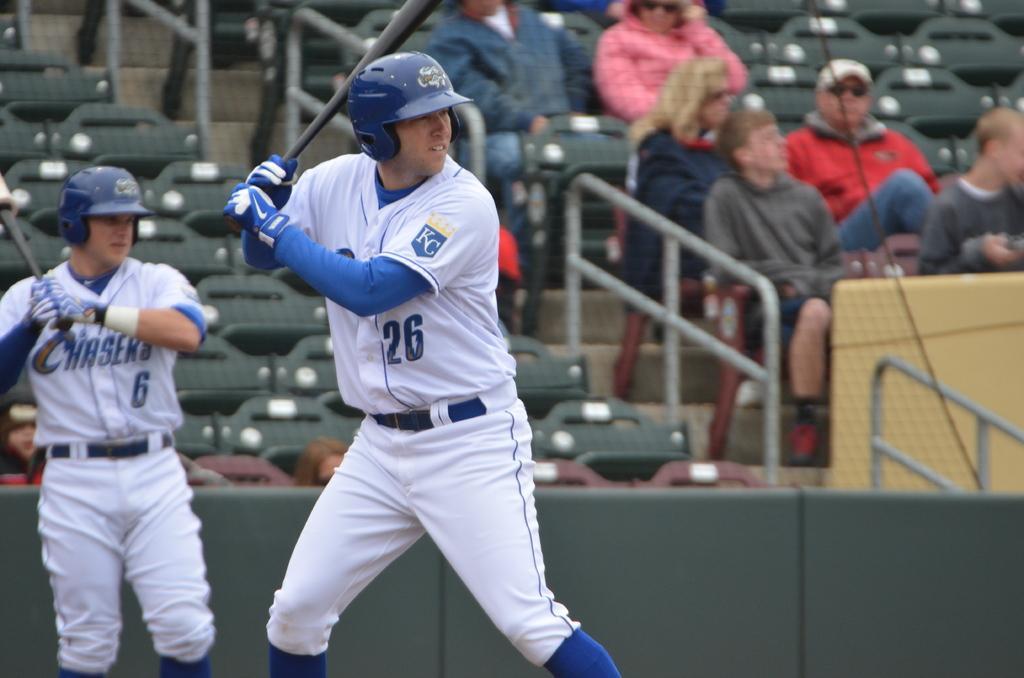Describe this image in one or two sentences. In this image in front there are two people playing baseball. Behind them there are people sitting on the chairs. There is a metal fence. There are stairs. 